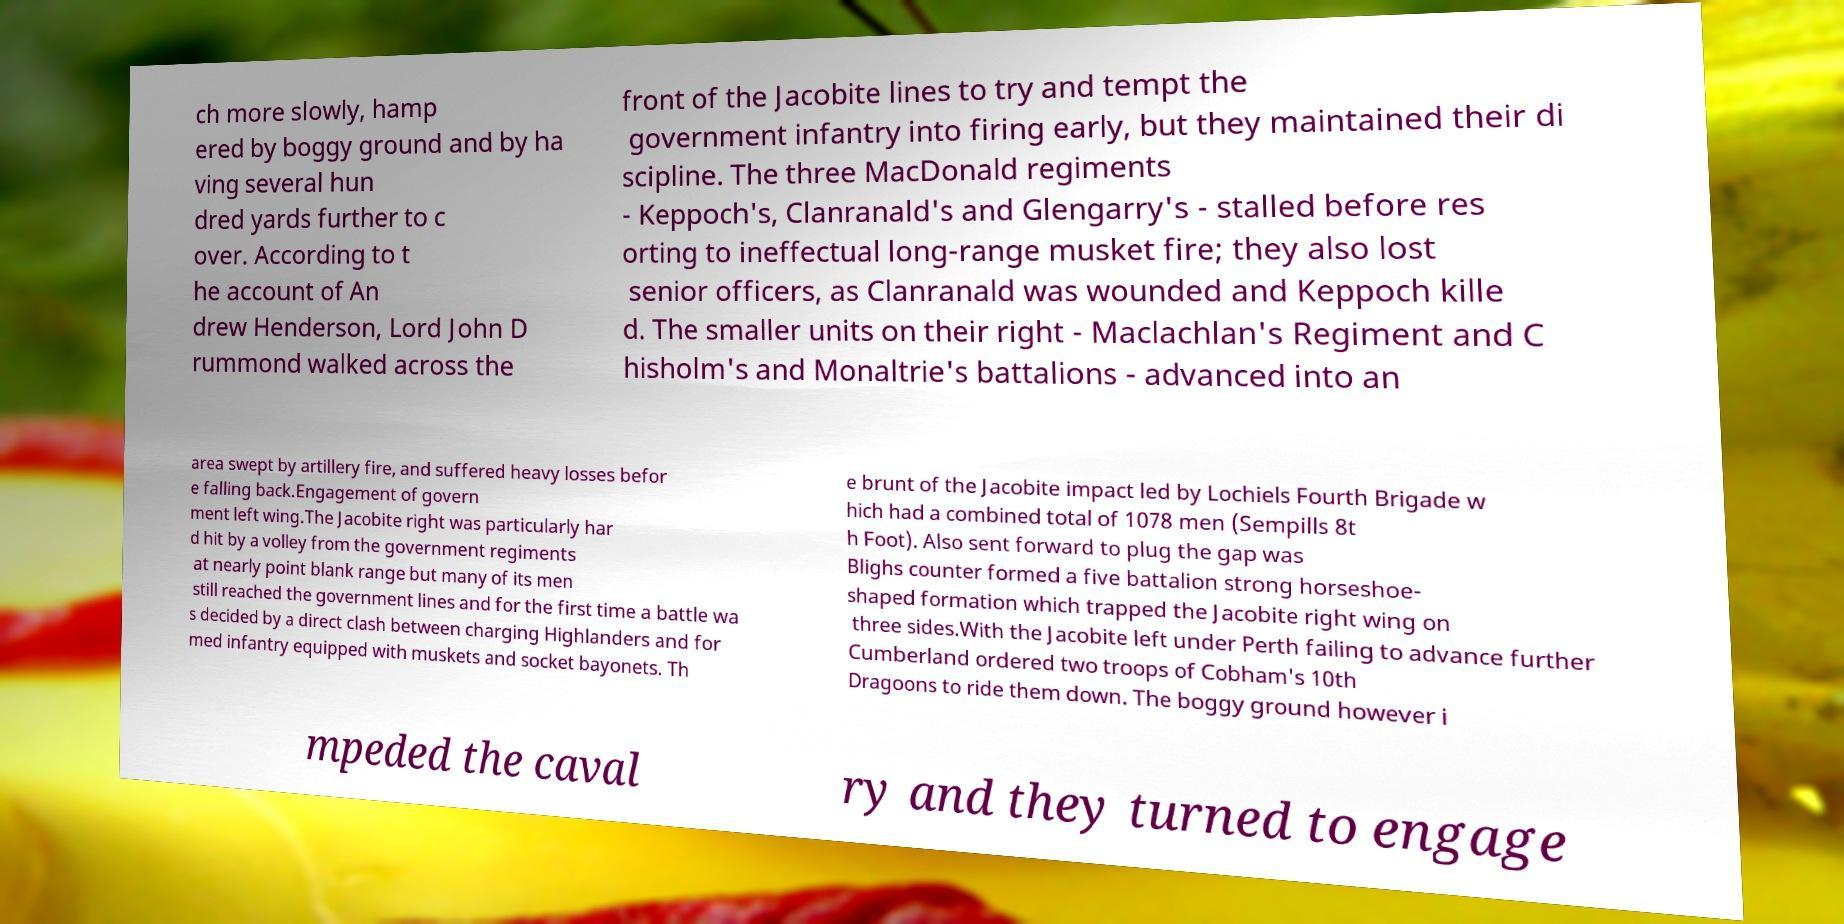Please identify and transcribe the text found in this image. ch more slowly, hamp ered by boggy ground and by ha ving several hun dred yards further to c over. According to t he account of An drew Henderson, Lord John D rummond walked across the front of the Jacobite lines to try and tempt the government infantry into firing early, but they maintained their di scipline. The three MacDonald regiments - Keppoch's, Clanranald's and Glengarry's - stalled before res orting to ineffectual long-range musket fire; they also lost senior officers, as Clanranald was wounded and Keppoch kille d. The smaller units on their right - Maclachlan's Regiment and C hisholm's and Monaltrie's battalions - advanced into an area swept by artillery fire, and suffered heavy losses befor e falling back.Engagement of govern ment left wing.The Jacobite right was particularly har d hit by a volley from the government regiments at nearly point blank range but many of its men still reached the government lines and for the first time a battle wa s decided by a direct clash between charging Highlanders and for med infantry equipped with muskets and socket bayonets. Th e brunt of the Jacobite impact led by Lochiels Fourth Brigade w hich had a combined total of 1078 men (Sempills 8t h Foot). Also sent forward to plug the gap was Blighs counter formed a five battalion strong horseshoe- shaped formation which trapped the Jacobite right wing on three sides.With the Jacobite left under Perth failing to advance further Cumberland ordered two troops of Cobham's 10th Dragoons to ride them down. The boggy ground however i mpeded the caval ry and they turned to engage 